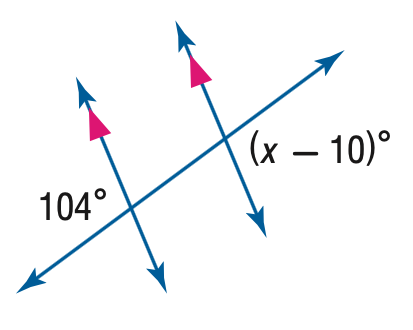Answer the mathemtical geometry problem and directly provide the correct option letter.
Question: Find the value of the variable x in the figure.
Choices: A: 86 B: 94 C: 96 D: 114 D 